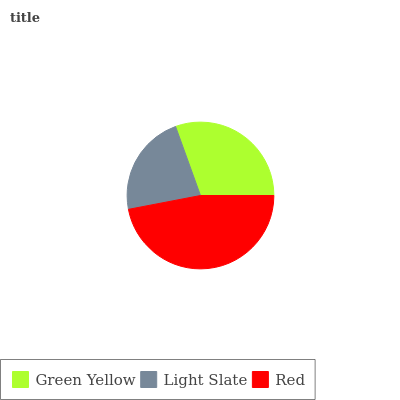Is Light Slate the minimum?
Answer yes or no. Yes. Is Red the maximum?
Answer yes or no. Yes. Is Red the minimum?
Answer yes or no. No. Is Light Slate the maximum?
Answer yes or no. No. Is Red greater than Light Slate?
Answer yes or no. Yes. Is Light Slate less than Red?
Answer yes or no. Yes. Is Light Slate greater than Red?
Answer yes or no. No. Is Red less than Light Slate?
Answer yes or no. No. Is Green Yellow the high median?
Answer yes or no. Yes. Is Green Yellow the low median?
Answer yes or no. Yes. Is Light Slate the high median?
Answer yes or no. No. Is Light Slate the low median?
Answer yes or no. No. 